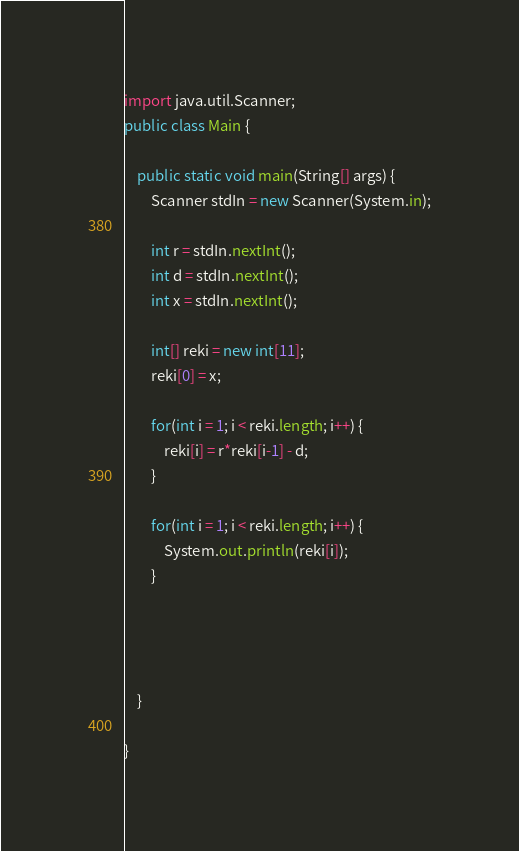Convert code to text. <code><loc_0><loc_0><loc_500><loc_500><_Java_>import java.util.Scanner;
public class Main {

	public static void main(String[] args) {
		Scanner stdIn = new Scanner(System.in);
		
		int r = stdIn.nextInt();
		int d = stdIn.nextInt();
		int x = stdIn.nextInt();
		
		int[] reki = new int[11];
		reki[0] = x;
		
		for(int i = 1; i < reki.length; i++) {
			reki[i] = r*reki[i-1] - d;
		}
		
		for(int i = 1; i < reki.length; i++) {
			System.out.println(reki[i]);
		}
		
		
		
		
	}

}
</code> 